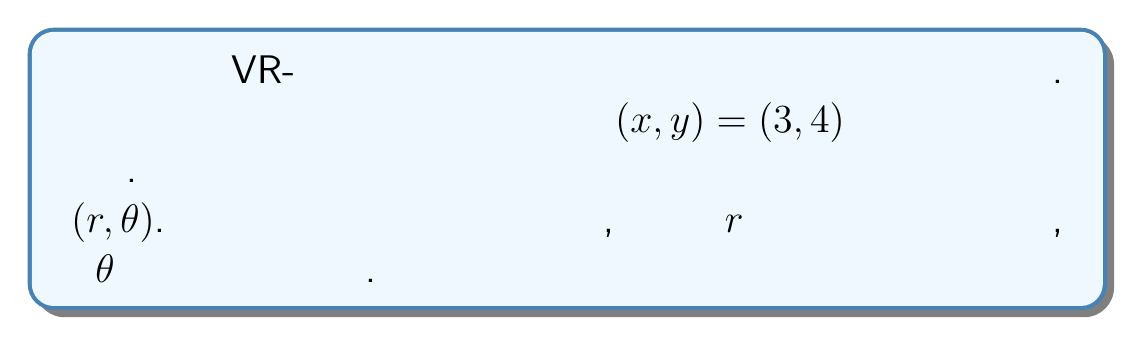Provide a solution to this math problem. Для преобразования декартовых координат $(x, y)$ в полярные координаты $(r, \theta)$ используем следующие формулы:

1) Для радиуса $r$:
   $$r = \sqrt{x^2 + y^2}$$

2) Для угла $\theta$ (в радианах):
   $$\theta = \arctan2(y, x)$$

Шаг 1: Вычисляем $r$
$$r = \sqrt{3^2 + 4^2} = \sqrt{9 + 16} = \sqrt{25} = 5$$

Шаг 2: Вычисляем $\theta$ в радианах
$$\theta = \arctan2(4, 3) \approx 0.9272952180016122$$

Шаг 3: Преобразуем $\theta$ из радиан в градусы
$$\theta_{degrees} = \theta_{radians} \cdot \frac{180°}{\pi} \approx 53.13010235415598°$$

Шаг 4: Округляем значения
$r \approx 5.0$ (округлено до одного десятичного знака)
$\theta \approx 53°$ (округлено до ближайшего градуса)
Answer: $(r, \theta) \approx (5.0, 53°)$ 